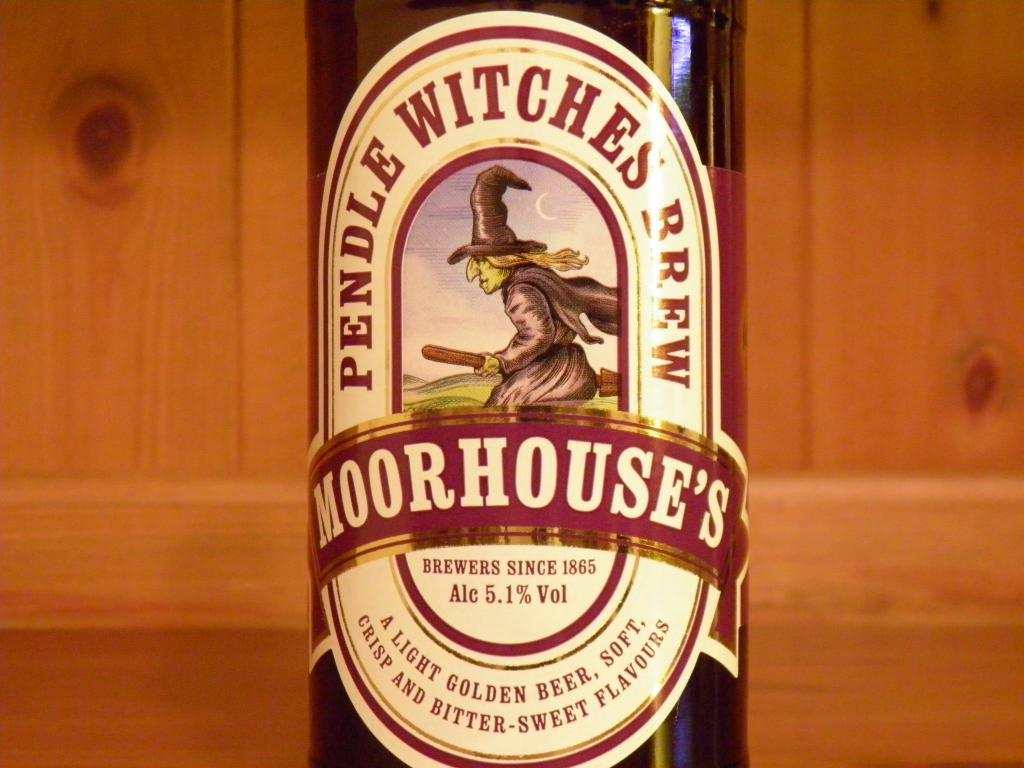Provide a one-sentence caption for the provided image. Moorhouse's Pendle Witches Brew is the name of the label of this IPA. 